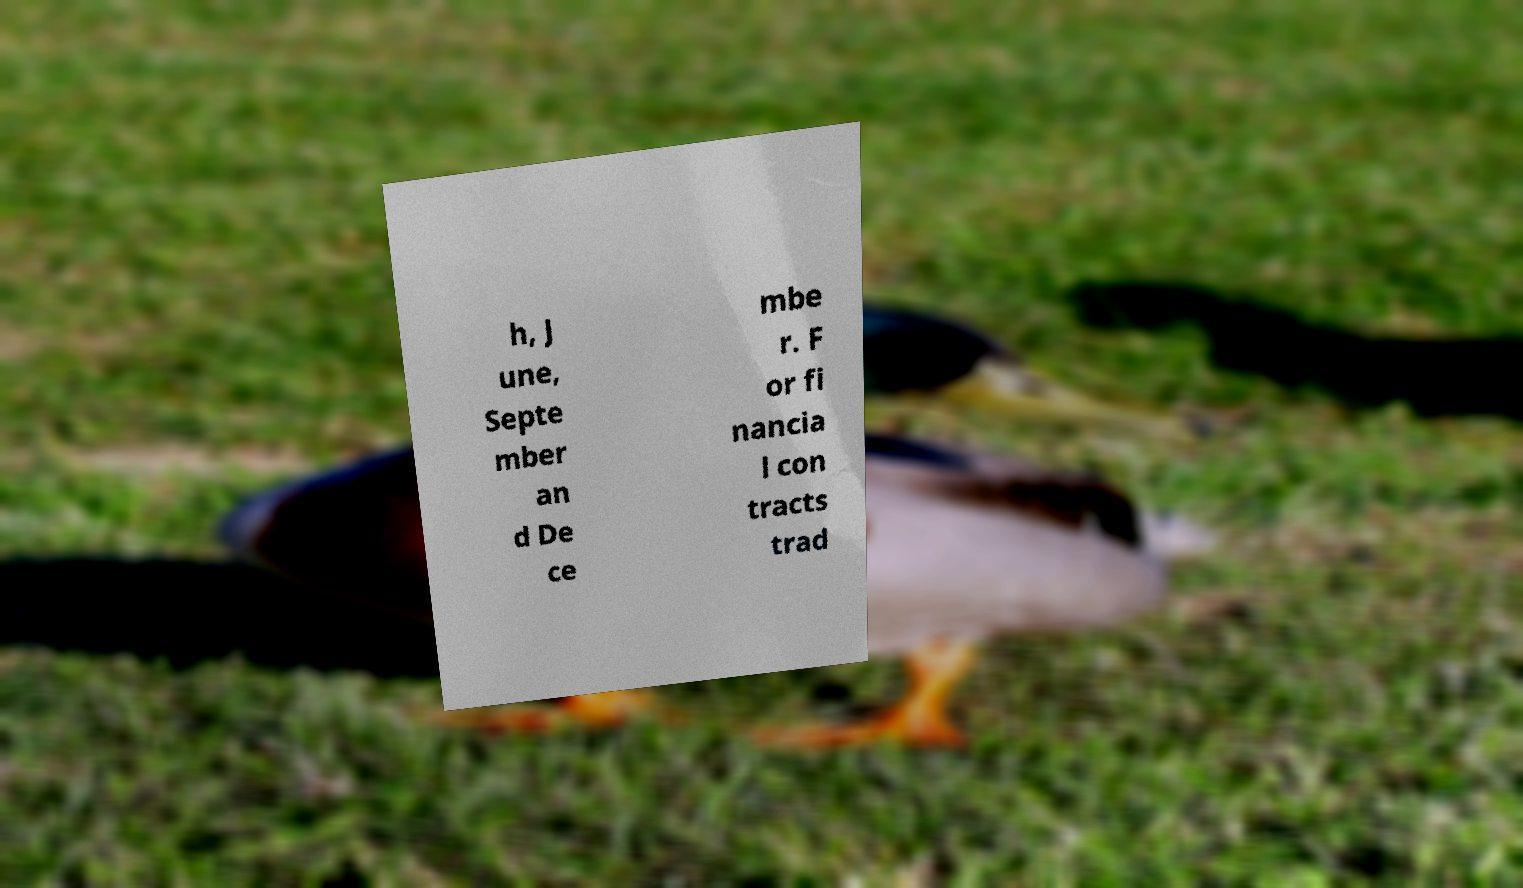Can you read and provide the text displayed in the image?This photo seems to have some interesting text. Can you extract and type it out for me? h, J une, Septe mber an d De ce mbe r. F or fi nancia l con tracts trad 